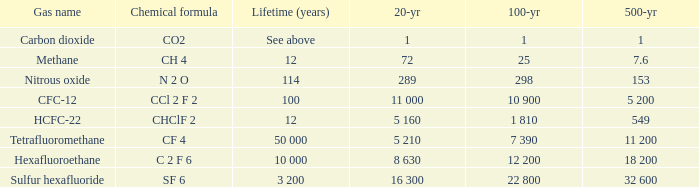What is the 500 year where 20 year is 289? 153.0. 